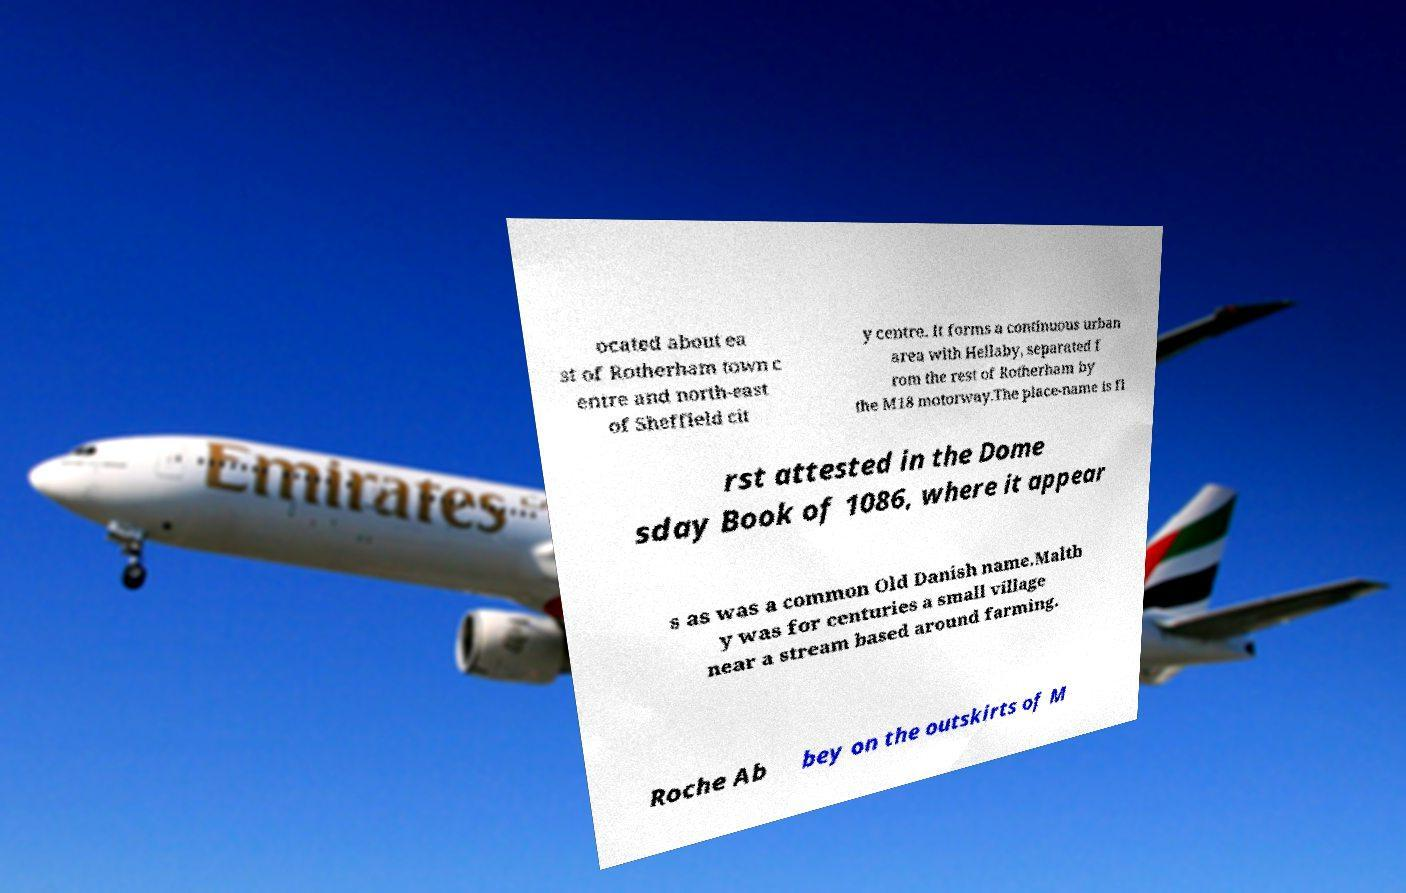Please read and relay the text visible in this image. What does it say? ocated about ea st of Rotherham town c entre and north-east of Sheffield cit y centre. It forms a continuous urban area with Hellaby, separated f rom the rest of Rotherham by the M18 motorway.The place-name is fi rst attested in the Dome sday Book of 1086, where it appear s as was a common Old Danish name.Maltb y was for centuries a small village near a stream based around farming. Roche Ab bey on the outskirts of M 